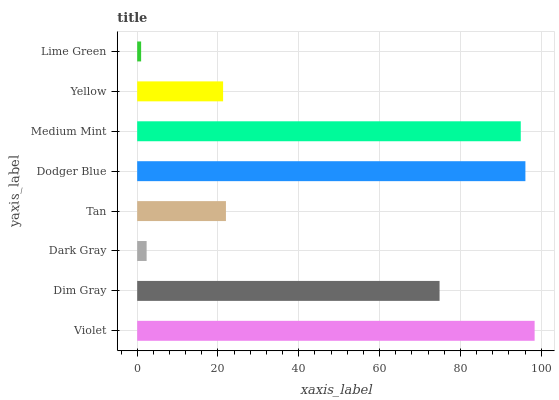Is Lime Green the minimum?
Answer yes or no. Yes. Is Violet the maximum?
Answer yes or no. Yes. Is Dim Gray the minimum?
Answer yes or no. No. Is Dim Gray the maximum?
Answer yes or no. No. Is Violet greater than Dim Gray?
Answer yes or no. Yes. Is Dim Gray less than Violet?
Answer yes or no. Yes. Is Dim Gray greater than Violet?
Answer yes or no. No. Is Violet less than Dim Gray?
Answer yes or no. No. Is Dim Gray the high median?
Answer yes or no. Yes. Is Tan the low median?
Answer yes or no. Yes. Is Medium Mint the high median?
Answer yes or no. No. Is Violet the low median?
Answer yes or no. No. 